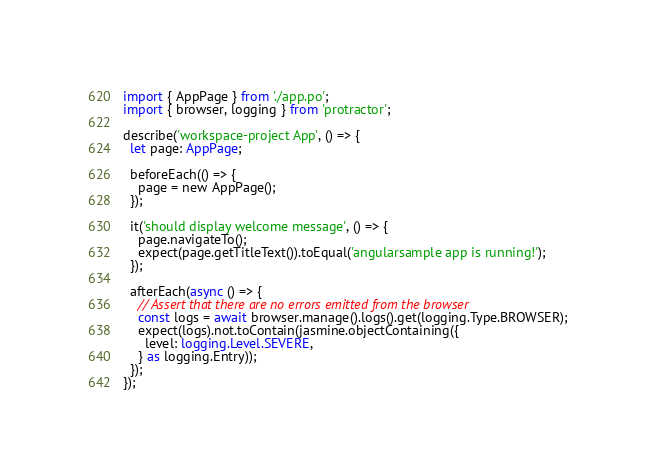Convert code to text. <code><loc_0><loc_0><loc_500><loc_500><_TypeScript_>import { AppPage } from './app.po';
import { browser, logging } from 'protractor';

describe('workspace-project App', () => {
  let page: AppPage;

  beforeEach(() => {
    page = new AppPage();
  });

  it('should display welcome message', () => {
    page.navigateTo();
    expect(page.getTitleText()).toEqual('angularsample app is running!');
  });

  afterEach(async () => {
    // Assert that there are no errors emitted from the browser
    const logs = await browser.manage().logs().get(logging.Type.BROWSER);
    expect(logs).not.toContain(jasmine.objectContaining({
      level: logging.Level.SEVERE,
    } as logging.Entry));
  });
});
</code> 